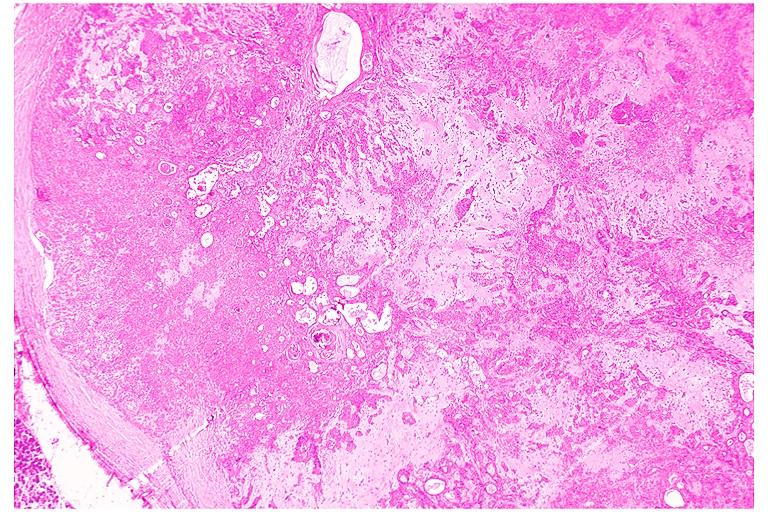does this image show pleomorphic adenoma benign mixed tumor?
Answer the question using a single word or phrase. Yes 